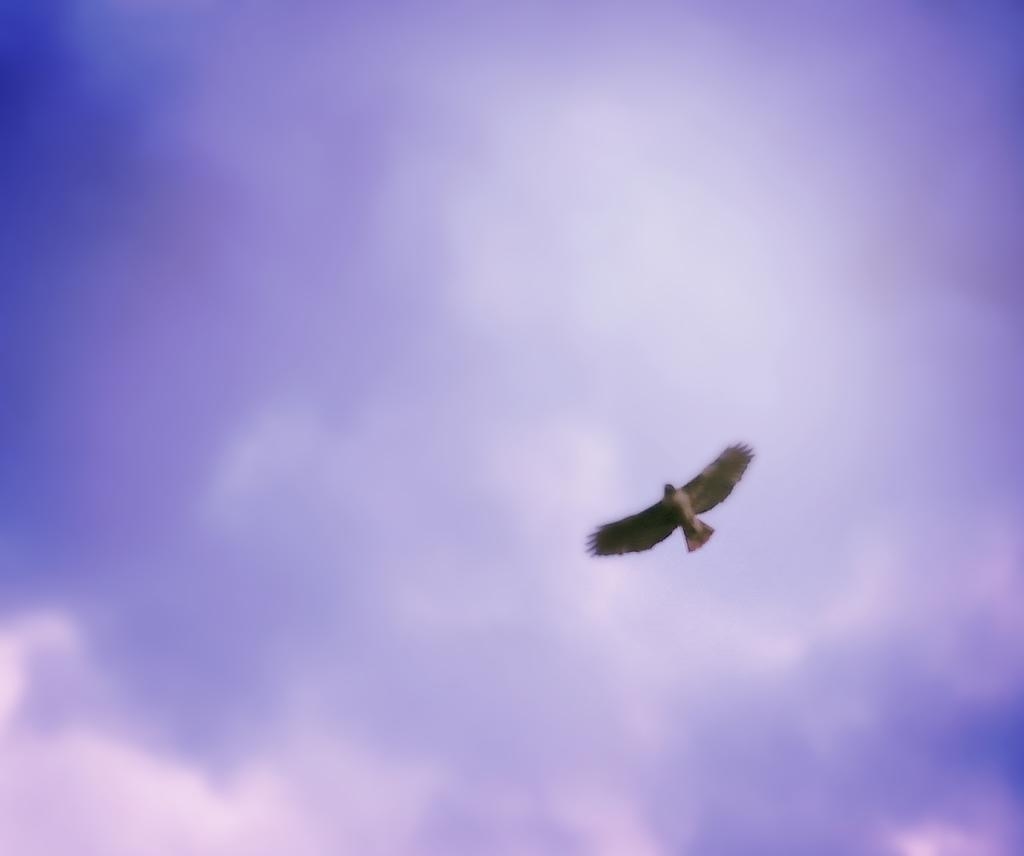What type of animal can be seen in the image? There is a bird in the image. What is the bird doing in the image? The bird is flying in the sky. What type of clouds can be seen in the image? There is no mention of clouds in the provided facts, so we cannot determine if clouds are present in the image. 